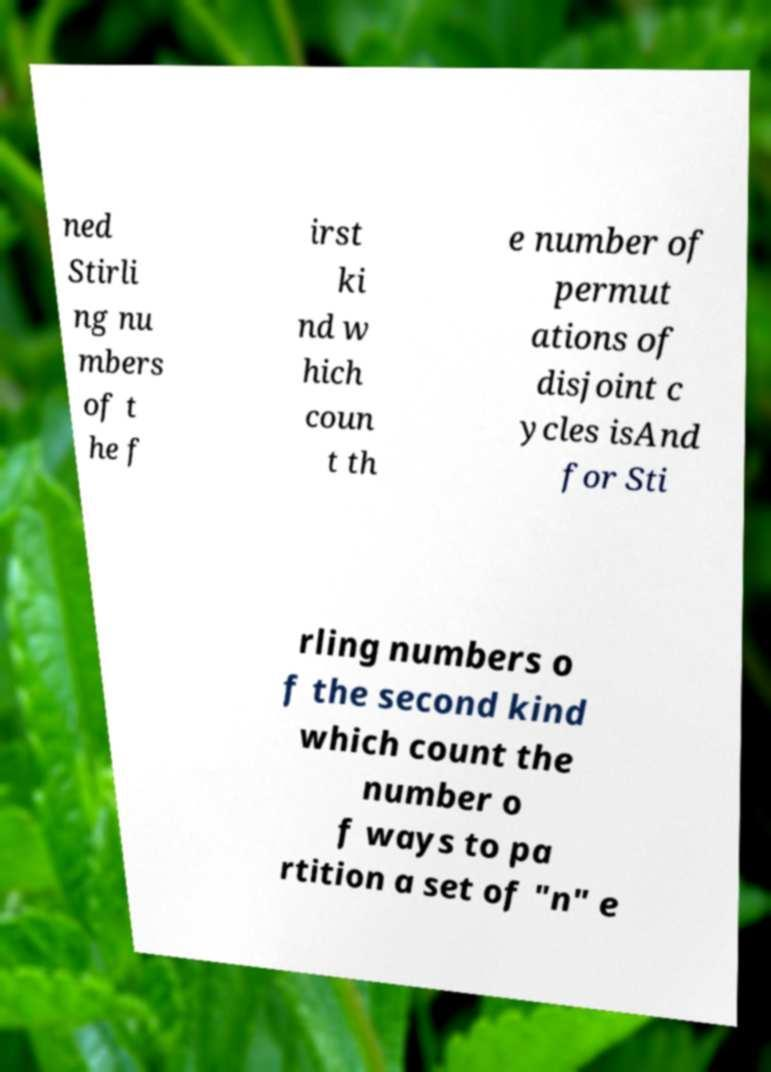Can you accurately transcribe the text from the provided image for me? ned Stirli ng nu mbers of t he f irst ki nd w hich coun t th e number of permut ations of disjoint c ycles isAnd for Sti rling numbers o f the second kind which count the number o f ways to pa rtition a set of "n" e 